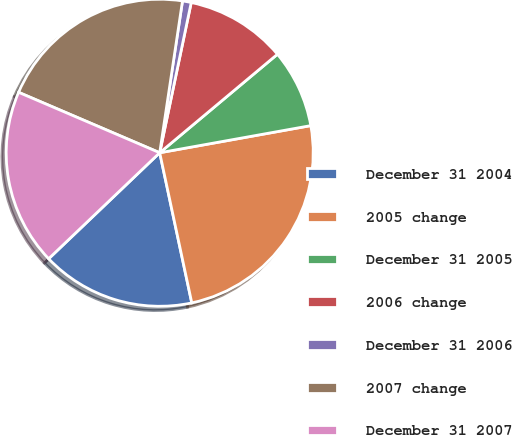Convert chart to OTSL. <chart><loc_0><loc_0><loc_500><loc_500><pie_chart><fcel>December 31 2004<fcel>2005 change<fcel>December 31 2005<fcel>2006 change<fcel>December 31 2006<fcel>2007 change<fcel>December 31 2007<nl><fcel>16.22%<fcel>24.48%<fcel>8.26%<fcel>10.62%<fcel>0.92%<fcel>20.93%<fcel>18.57%<nl></chart> 